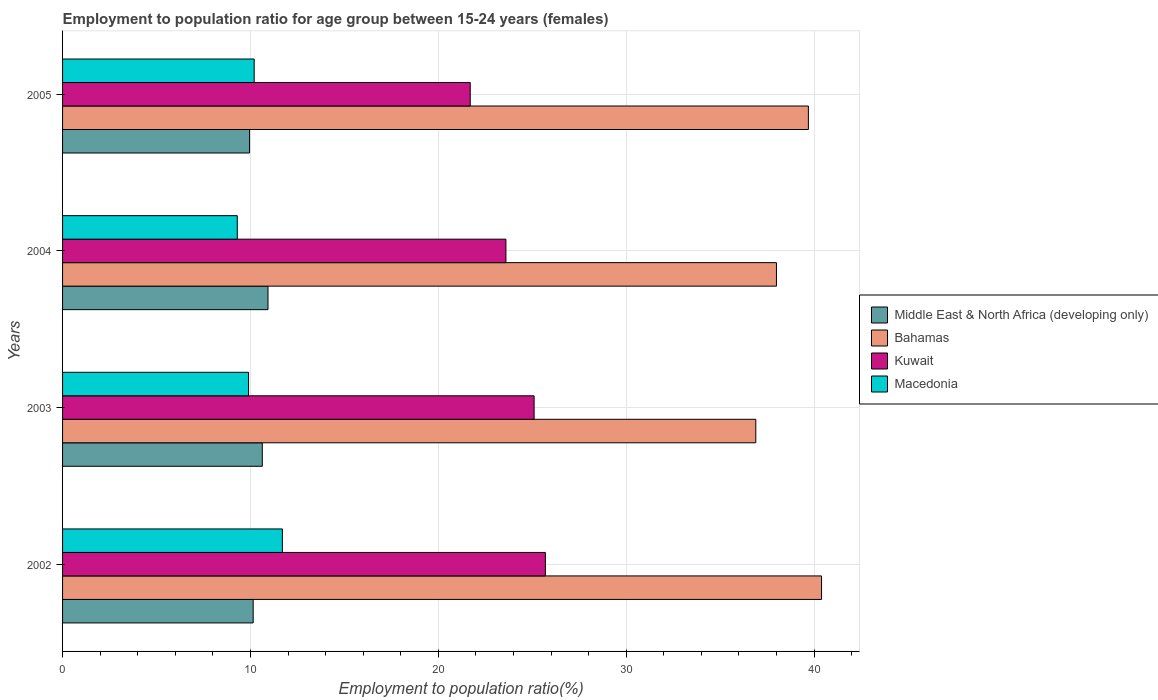How many different coloured bars are there?
Ensure brevity in your answer.  4. Are the number of bars on each tick of the Y-axis equal?
Give a very brief answer. Yes. What is the label of the 4th group of bars from the top?
Your answer should be compact. 2002. What is the employment to population ratio in Macedonia in 2003?
Offer a terse response. 9.9. Across all years, what is the maximum employment to population ratio in Macedonia?
Give a very brief answer. 11.7. Across all years, what is the minimum employment to population ratio in Kuwait?
Offer a very short reply. 21.7. What is the total employment to population ratio in Kuwait in the graph?
Ensure brevity in your answer.  96.1. What is the difference between the employment to population ratio in Middle East & North Africa (developing only) in 2003 and that in 2005?
Provide a succinct answer. 0.68. What is the difference between the employment to population ratio in Kuwait in 2004 and the employment to population ratio in Bahamas in 2005?
Keep it short and to the point. -16.1. What is the average employment to population ratio in Middle East & North Africa (developing only) per year?
Make the answer very short. 10.42. In the year 2005, what is the difference between the employment to population ratio in Middle East & North Africa (developing only) and employment to population ratio in Macedonia?
Your answer should be compact. -0.25. In how many years, is the employment to population ratio in Middle East & North Africa (developing only) greater than 20 %?
Keep it short and to the point. 0. What is the ratio of the employment to population ratio in Bahamas in 2003 to that in 2004?
Your answer should be very brief. 0.97. What is the difference between the highest and the second highest employment to population ratio in Macedonia?
Give a very brief answer. 1.5. Is the sum of the employment to population ratio in Bahamas in 2003 and 2005 greater than the maximum employment to population ratio in Kuwait across all years?
Your answer should be compact. Yes. What does the 2nd bar from the top in 2003 represents?
Your answer should be compact. Kuwait. What does the 2nd bar from the bottom in 2005 represents?
Offer a terse response. Bahamas. Is it the case that in every year, the sum of the employment to population ratio in Middle East & North Africa (developing only) and employment to population ratio in Bahamas is greater than the employment to population ratio in Kuwait?
Your answer should be very brief. Yes. How many bars are there?
Provide a succinct answer. 16. Are all the bars in the graph horizontal?
Your response must be concise. Yes. How many years are there in the graph?
Make the answer very short. 4. Are the values on the major ticks of X-axis written in scientific E-notation?
Provide a short and direct response. No. Does the graph contain any zero values?
Your answer should be compact. No. Where does the legend appear in the graph?
Provide a succinct answer. Center right. What is the title of the graph?
Give a very brief answer. Employment to population ratio for age group between 15-24 years (females). Does "Nepal" appear as one of the legend labels in the graph?
Offer a very short reply. No. What is the label or title of the Y-axis?
Ensure brevity in your answer.  Years. What is the Employment to population ratio(%) of Middle East & North Africa (developing only) in 2002?
Your response must be concise. 10.15. What is the Employment to population ratio(%) in Bahamas in 2002?
Give a very brief answer. 40.4. What is the Employment to population ratio(%) of Kuwait in 2002?
Your answer should be compact. 25.7. What is the Employment to population ratio(%) of Macedonia in 2002?
Offer a very short reply. 11.7. What is the Employment to population ratio(%) in Middle East & North Africa (developing only) in 2003?
Provide a succinct answer. 10.63. What is the Employment to population ratio(%) of Bahamas in 2003?
Ensure brevity in your answer.  36.9. What is the Employment to population ratio(%) in Kuwait in 2003?
Your answer should be very brief. 25.1. What is the Employment to population ratio(%) in Macedonia in 2003?
Provide a short and direct response. 9.9. What is the Employment to population ratio(%) in Middle East & North Africa (developing only) in 2004?
Give a very brief answer. 10.94. What is the Employment to population ratio(%) in Kuwait in 2004?
Make the answer very short. 23.6. What is the Employment to population ratio(%) in Macedonia in 2004?
Make the answer very short. 9.3. What is the Employment to population ratio(%) of Middle East & North Africa (developing only) in 2005?
Keep it short and to the point. 9.95. What is the Employment to population ratio(%) in Bahamas in 2005?
Ensure brevity in your answer.  39.7. What is the Employment to population ratio(%) in Kuwait in 2005?
Offer a terse response. 21.7. What is the Employment to population ratio(%) in Macedonia in 2005?
Keep it short and to the point. 10.2. Across all years, what is the maximum Employment to population ratio(%) of Middle East & North Africa (developing only)?
Your response must be concise. 10.94. Across all years, what is the maximum Employment to population ratio(%) of Bahamas?
Give a very brief answer. 40.4. Across all years, what is the maximum Employment to population ratio(%) in Kuwait?
Provide a short and direct response. 25.7. Across all years, what is the maximum Employment to population ratio(%) of Macedonia?
Make the answer very short. 11.7. Across all years, what is the minimum Employment to population ratio(%) in Middle East & North Africa (developing only)?
Give a very brief answer. 9.95. Across all years, what is the minimum Employment to population ratio(%) in Bahamas?
Your answer should be compact. 36.9. Across all years, what is the minimum Employment to population ratio(%) of Kuwait?
Provide a succinct answer. 21.7. Across all years, what is the minimum Employment to population ratio(%) of Macedonia?
Offer a very short reply. 9.3. What is the total Employment to population ratio(%) of Middle East & North Africa (developing only) in the graph?
Ensure brevity in your answer.  41.67. What is the total Employment to population ratio(%) of Bahamas in the graph?
Provide a succinct answer. 155. What is the total Employment to population ratio(%) of Kuwait in the graph?
Offer a terse response. 96.1. What is the total Employment to population ratio(%) of Macedonia in the graph?
Your answer should be compact. 41.1. What is the difference between the Employment to population ratio(%) of Middle East & North Africa (developing only) in 2002 and that in 2003?
Make the answer very short. -0.49. What is the difference between the Employment to population ratio(%) in Bahamas in 2002 and that in 2003?
Your answer should be very brief. 3.5. What is the difference between the Employment to population ratio(%) in Kuwait in 2002 and that in 2003?
Your answer should be very brief. 0.6. What is the difference between the Employment to population ratio(%) of Middle East & North Africa (developing only) in 2002 and that in 2004?
Give a very brief answer. -0.79. What is the difference between the Employment to population ratio(%) in Kuwait in 2002 and that in 2004?
Keep it short and to the point. 2.1. What is the difference between the Employment to population ratio(%) in Macedonia in 2002 and that in 2004?
Your answer should be very brief. 2.4. What is the difference between the Employment to population ratio(%) in Middle East & North Africa (developing only) in 2002 and that in 2005?
Your answer should be very brief. 0.19. What is the difference between the Employment to population ratio(%) in Kuwait in 2002 and that in 2005?
Your answer should be very brief. 4. What is the difference between the Employment to population ratio(%) in Macedonia in 2002 and that in 2005?
Your answer should be compact. 1.5. What is the difference between the Employment to population ratio(%) of Middle East & North Africa (developing only) in 2003 and that in 2004?
Your answer should be compact. -0.3. What is the difference between the Employment to population ratio(%) of Kuwait in 2003 and that in 2004?
Give a very brief answer. 1.5. What is the difference between the Employment to population ratio(%) of Macedonia in 2003 and that in 2004?
Provide a short and direct response. 0.6. What is the difference between the Employment to population ratio(%) of Middle East & North Africa (developing only) in 2003 and that in 2005?
Keep it short and to the point. 0.68. What is the difference between the Employment to population ratio(%) in Bahamas in 2003 and that in 2005?
Your answer should be compact. -2.8. What is the difference between the Employment to population ratio(%) in Middle East & North Africa (developing only) in 2004 and that in 2005?
Provide a succinct answer. 0.98. What is the difference between the Employment to population ratio(%) of Bahamas in 2004 and that in 2005?
Your answer should be very brief. -1.7. What is the difference between the Employment to population ratio(%) in Macedonia in 2004 and that in 2005?
Your response must be concise. -0.9. What is the difference between the Employment to population ratio(%) in Middle East & North Africa (developing only) in 2002 and the Employment to population ratio(%) in Bahamas in 2003?
Give a very brief answer. -26.75. What is the difference between the Employment to population ratio(%) of Middle East & North Africa (developing only) in 2002 and the Employment to population ratio(%) of Kuwait in 2003?
Your answer should be very brief. -14.95. What is the difference between the Employment to population ratio(%) in Middle East & North Africa (developing only) in 2002 and the Employment to population ratio(%) in Macedonia in 2003?
Make the answer very short. 0.25. What is the difference between the Employment to population ratio(%) in Bahamas in 2002 and the Employment to population ratio(%) in Macedonia in 2003?
Make the answer very short. 30.5. What is the difference between the Employment to population ratio(%) in Kuwait in 2002 and the Employment to population ratio(%) in Macedonia in 2003?
Give a very brief answer. 15.8. What is the difference between the Employment to population ratio(%) of Middle East & North Africa (developing only) in 2002 and the Employment to population ratio(%) of Bahamas in 2004?
Provide a succinct answer. -27.85. What is the difference between the Employment to population ratio(%) of Middle East & North Africa (developing only) in 2002 and the Employment to population ratio(%) of Kuwait in 2004?
Your answer should be compact. -13.45. What is the difference between the Employment to population ratio(%) in Middle East & North Africa (developing only) in 2002 and the Employment to population ratio(%) in Macedonia in 2004?
Your answer should be very brief. 0.85. What is the difference between the Employment to population ratio(%) of Bahamas in 2002 and the Employment to population ratio(%) of Kuwait in 2004?
Your answer should be very brief. 16.8. What is the difference between the Employment to population ratio(%) in Bahamas in 2002 and the Employment to population ratio(%) in Macedonia in 2004?
Offer a very short reply. 31.1. What is the difference between the Employment to population ratio(%) of Middle East & North Africa (developing only) in 2002 and the Employment to population ratio(%) of Bahamas in 2005?
Make the answer very short. -29.55. What is the difference between the Employment to population ratio(%) in Middle East & North Africa (developing only) in 2002 and the Employment to population ratio(%) in Kuwait in 2005?
Provide a short and direct response. -11.55. What is the difference between the Employment to population ratio(%) of Middle East & North Africa (developing only) in 2002 and the Employment to population ratio(%) of Macedonia in 2005?
Your answer should be compact. -0.05. What is the difference between the Employment to population ratio(%) in Bahamas in 2002 and the Employment to population ratio(%) in Macedonia in 2005?
Provide a succinct answer. 30.2. What is the difference between the Employment to population ratio(%) in Kuwait in 2002 and the Employment to population ratio(%) in Macedonia in 2005?
Your response must be concise. 15.5. What is the difference between the Employment to population ratio(%) of Middle East & North Africa (developing only) in 2003 and the Employment to population ratio(%) of Bahamas in 2004?
Ensure brevity in your answer.  -27.37. What is the difference between the Employment to population ratio(%) in Middle East & North Africa (developing only) in 2003 and the Employment to population ratio(%) in Kuwait in 2004?
Ensure brevity in your answer.  -12.97. What is the difference between the Employment to population ratio(%) in Middle East & North Africa (developing only) in 2003 and the Employment to population ratio(%) in Macedonia in 2004?
Your response must be concise. 1.33. What is the difference between the Employment to population ratio(%) in Bahamas in 2003 and the Employment to population ratio(%) in Macedonia in 2004?
Provide a short and direct response. 27.6. What is the difference between the Employment to population ratio(%) of Kuwait in 2003 and the Employment to population ratio(%) of Macedonia in 2004?
Ensure brevity in your answer.  15.8. What is the difference between the Employment to population ratio(%) of Middle East & North Africa (developing only) in 2003 and the Employment to population ratio(%) of Bahamas in 2005?
Offer a very short reply. -29.07. What is the difference between the Employment to population ratio(%) of Middle East & North Africa (developing only) in 2003 and the Employment to population ratio(%) of Kuwait in 2005?
Make the answer very short. -11.07. What is the difference between the Employment to population ratio(%) of Middle East & North Africa (developing only) in 2003 and the Employment to population ratio(%) of Macedonia in 2005?
Make the answer very short. 0.43. What is the difference between the Employment to population ratio(%) of Bahamas in 2003 and the Employment to population ratio(%) of Kuwait in 2005?
Give a very brief answer. 15.2. What is the difference between the Employment to population ratio(%) of Bahamas in 2003 and the Employment to population ratio(%) of Macedonia in 2005?
Ensure brevity in your answer.  26.7. What is the difference between the Employment to population ratio(%) of Middle East & North Africa (developing only) in 2004 and the Employment to population ratio(%) of Bahamas in 2005?
Provide a succinct answer. -28.76. What is the difference between the Employment to population ratio(%) in Middle East & North Africa (developing only) in 2004 and the Employment to population ratio(%) in Kuwait in 2005?
Offer a very short reply. -10.76. What is the difference between the Employment to population ratio(%) in Middle East & North Africa (developing only) in 2004 and the Employment to population ratio(%) in Macedonia in 2005?
Offer a terse response. 0.74. What is the difference between the Employment to population ratio(%) of Bahamas in 2004 and the Employment to population ratio(%) of Kuwait in 2005?
Keep it short and to the point. 16.3. What is the difference between the Employment to population ratio(%) of Bahamas in 2004 and the Employment to population ratio(%) of Macedonia in 2005?
Your response must be concise. 27.8. What is the average Employment to population ratio(%) in Middle East & North Africa (developing only) per year?
Give a very brief answer. 10.42. What is the average Employment to population ratio(%) in Bahamas per year?
Give a very brief answer. 38.75. What is the average Employment to population ratio(%) of Kuwait per year?
Offer a very short reply. 24.02. What is the average Employment to population ratio(%) of Macedonia per year?
Ensure brevity in your answer.  10.28. In the year 2002, what is the difference between the Employment to population ratio(%) of Middle East & North Africa (developing only) and Employment to population ratio(%) of Bahamas?
Keep it short and to the point. -30.25. In the year 2002, what is the difference between the Employment to population ratio(%) in Middle East & North Africa (developing only) and Employment to population ratio(%) in Kuwait?
Make the answer very short. -15.55. In the year 2002, what is the difference between the Employment to population ratio(%) in Middle East & North Africa (developing only) and Employment to population ratio(%) in Macedonia?
Provide a short and direct response. -1.55. In the year 2002, what is the difference between the Employment to population ratio(%) in Bahamas and Employment to population ratio(%) in Kuwait?
Provide a short and direct response. 14.7. In the year 2002, what is the difference between the Employment to population ratio(%) of Bahamas and Employment to population ratio(%) of Macedonia?
Make the answer very short. 28.7. In the year 2003, what is the difference between the Employment to population ratio(%) in Middle East & North Africa (developing only) and Employment to population ratio(%) in Bahamas?
Ensure brevity in your answer.  -26.27. In the year 2003, what is the difference between the Employment to population ratio(%) of Middle East & North Africa (developing only) and Employment to population ratio(%) of Kuwait?
Give a very brief answer. -14.47. In the year 2003, what is the difference between the Employment to population ratio(%) in Middle East & North Africa (developing only) and Employment to population ratio(%) in Macedonia?
Your response must be concise. 0.73. In the year 2003, what is the difference between the Employment to population ratio(%) in Bahamas and Employment to population ratio(%) in Kuwait?
Give a very brief answer. 11.8. In the year 2003, what is the difference between the Employment to population ratio(%) of Bahamas and Employment to population ratio(%) of Macedonia?
Provide a short and direct response. 27. In the year 2003, what is the difference between the Employment to population ratio(%) in Kuwait and Employment to population ratio(%) in Macedonia?
Keep it short and to the point. 15.2. In the year 2004, what is the difference between the Employment to population ratio(%) of Middle East & North Africa (developing only) and Employment to population ratio(%) of Bahamas?
Ensure brevity in your answer.  -27.06. In the year 2004, what is the difference between the Employment to population ratio(%) in Middle East & North Africa (developing only) and Employment to population ratio(%) in Kuwait?
Your response must be concise. -12.66. In the year 2004, what is the difference between the Employment to population ratio(%) in Middle East & North Africa (developing only) and Employment to population ratio(%) in Macedonia?
Offer a very short reply. 1.64. In the year 2004, what is the difference between the Employment to population ratio(%) in Bahamas and Employment to population ratio(%) in Kuwait?
Make the answer very short. 14.4. In the year 2004, what is the difference between the Employment to population ratio(%) of Bahamas and Employment to population ratio(%) of Macedonia?
Keep it short and to the point. 28.7. In the year 2005, what is the difference between the Employment to population ratio(%) in Middle East & North Africa (developing only) and Employment to population ratio(%) in Bahamas?
Provide a short and direct response. -29.75. In the year 2005, what is the difference between the Employment to population ratio(%) of Middle East & North Africa (developing only) and Employment to population ratio(%) of Kuwait?
Provide a succinct answer. -11.75. In the year 2005, what is the difference between the Employment to population ratio(%) in Middle East & North Africa (developing only) and Employment to population ratio(%) in Macedonia?
Your answer should be compact. -0.25. In the year 2005, what is the difference between the Employment to population ratio(%) in Bahamas and Employment to population ratio(%) in Kuwait?
Keep it short and to the point. 18. In the year 2005, what is the difference between the Employment to population ratio(%) in Bahamas and Employment to population ratio(%) in Macedonia?
Ensure brevity in your answer.  29.5. What is the ratio of the Employment to population ratio(%) of Middle East & North Africa (developing only) in 2002 to that in 2003?
Keep it short and to the point. 0.95. What is the ratio of the Employment to population ratio(%) of Bahamas in 2002 to that in 2003?
Ensure brevity in your answer.  1.09. What is the ratio of the Employment to population ratio(%) in Kuwait in 2002 to that in 2003?
Your answer should be compact. 1.02. What is the ratio of the Employment to population ratio(%) of Macedonia in 2002 to that in 2003?
Make the answer very short. 1.18. What is the ratio of the Employment to population ratio(%) of Middle East & North Africa (developing only) in 2002 to that in 2004?
Offer a terse response. 0.93. What is the ratio of the Employment to population ratio(%) in Bahamas in 2002 to that in 2004?
Your answer should be very brief. 1.06. What is the ratio of the Employment to population ratio(%) of Kuwait in 2002 to that in 2004?
Ensure brevity in your answer.  1.09. What is the ratio of the Employment to population ratio(%) in Macedonia in 2002 to that in 2004?
Your answer should be compact. 1.26. What is the ratio of the Employment to population ratio(%) of Middle East & North Africa (developing only) in 2002 to that in 2005?
Provide a succinct answer. 1.02. What is the ratio of the Employment to population ratio(%) in Bahamas in 2002 to that in 2005?
Provide a succinct answer. 1.02. What is the ratio of the Employment to population ratio(%) in Kuwait in 2002 to that in 2005?
Provide a short and direct response. 1.18. What is the ratio of the Employment to population ratio(%) in Macedonia in 2002 to that in 2005?
Offer a terse response. 1.15. What is the ratio of the Employment to population ratio(%) in Middle East & North Africa (developing only) in 2003 to that in 2004?
Offer a terse response. 0.97. What is the ratio of the Employment to population ratio(%) of Bahamas in 2003 to that in 2004?
Keep it short and to the point. 0.97. What is the ratio of the Employment to population ratio(%) of Kuwait in 2003 to that in 2004?
Offer a terse response. 1.06. What is the ratio of the Employment to population ratio(%) in Macedonia in 2003 to that in 2004?
Make the answer very short. 1.06. What is the ratio of the Employment to population ratio(%) of Middle East & North Africa (developing only) in 2003 to that in 2005?
Ensure brevity in your answer.  1.07. What is the ratio of the Employment to population ratio(%) of Bahamas in 2003 to that in 2005?
Provide a succinct answer. 0.93. What is the ratio of the Employment to population ratio(%) of Kuwait in 2003 to that in 2005?
Offer a terse response. 1.16. What is the ratio of the Employment to population ratio(%) of Macedonia in 2003 to that in 2005?
Offer a very short reply. 0.97. What is the ratio of the Employment to population ratio(%) of Middle East & North Africa (developing only) in 2004 to that in 2005?
Your response must be concise. 1.1. What is the ratio of the Employment to population ratio(%) of Bahamas in 2004 to that in 2005?
Your answer should be compact. 0.96. What is the ratio of the Employment to population ratio(%) in Kuwait in 2004 to that in 2005?
Give a very brief answer. 1.09. What is the ratio of the Employment to population ratio(%) of Macedonia in 2004 to that in 2005?
Make the answer very short. 0.91. What is the difference between the highest and the second highest Employment to population ratio(%) of Middle East & North Africa (developing only)?
Ensure brevity in your answer.  0.3. What is the difference between the highest and the second highest Employment to population ratio(%) in Bahamas?
Offer a very short reply. 0.7. What is the difference between the highest and the second highest Employment to population ratio(%) of Kuwait?
Provide a short and direct response. 0.6. What is the difference between the highest and the lowest Employment to population ratio(%) of Middle East & North Africa (developing only)?
Provide a succinct answer. 0.98. What is the difference between the highest and the lowest Employment to population ratio(%) of Bahamas?
Provide a short and direct response. 3.5. 